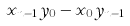Convert formula to latex. <formula><loc_0><loc_0><loc_500><loc_500>x _ { n - 1 } y _ { 0 } - x _ { 0 } y _ { n - 1 }</formula> 